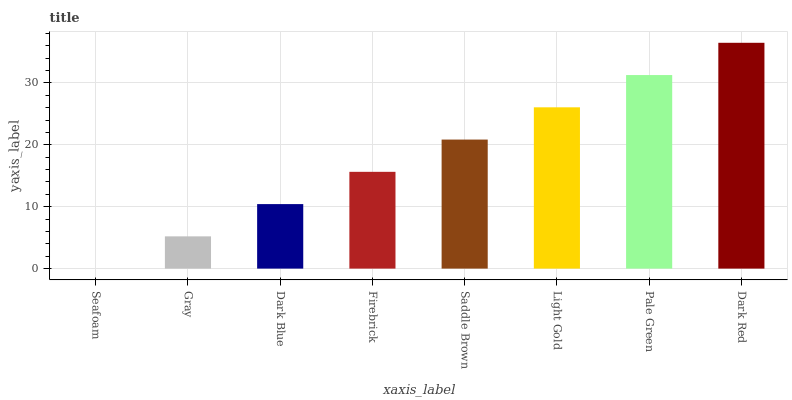Is Seafoam the minimum?
Answer yes or no. Yes. Is Dark Red the maximum?
Answer yes or no. Yes. Is Gray the minimum?
Answer yes or no. No. Is Gray the maximum?
Answer yes or no. No. Is Gray greater than Seafoam?
Answer yes or no. Yes. Is Seafoam less than Gray?
Answer yes or no. Yes. Is Seafoam greater than Gray?
Answer yes or no. No. Is Gray less than Seafoam?
Answer yes or no. No. Is Saddle Brown the high median?
Answer yes or no. Yes. Is Firebrick the low median?
Answer yes or no. Yes. Is Seafoam the high median?
Answer yes or no. No. Is Seafoam the low median?
Answer yes or no. No. 